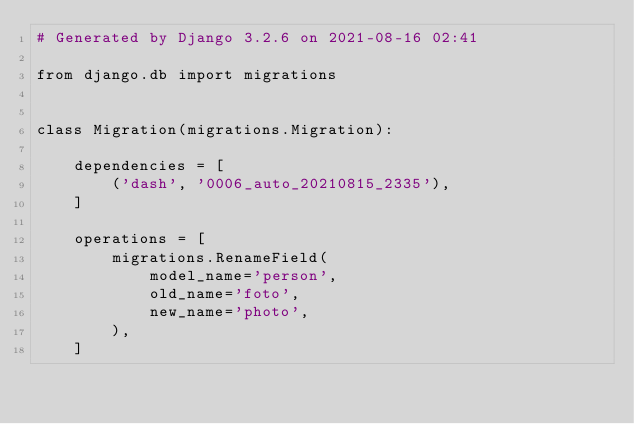<code> <loc_0><loc_0><loc_500><loc_500><_Python_># Generated by Django 3.2.6 on 2021-08-16 02:41

from django.db import migrations


class Migration(migrations.Migration):

    dependencies = [
        ('dash', '0006_auto_20210815_2335'),
    ]

    operations = [
        migrations.RenameField(
            model_name='person',
            old_name='foto',
            new_name='photo',
        ),
    ]
</code> 